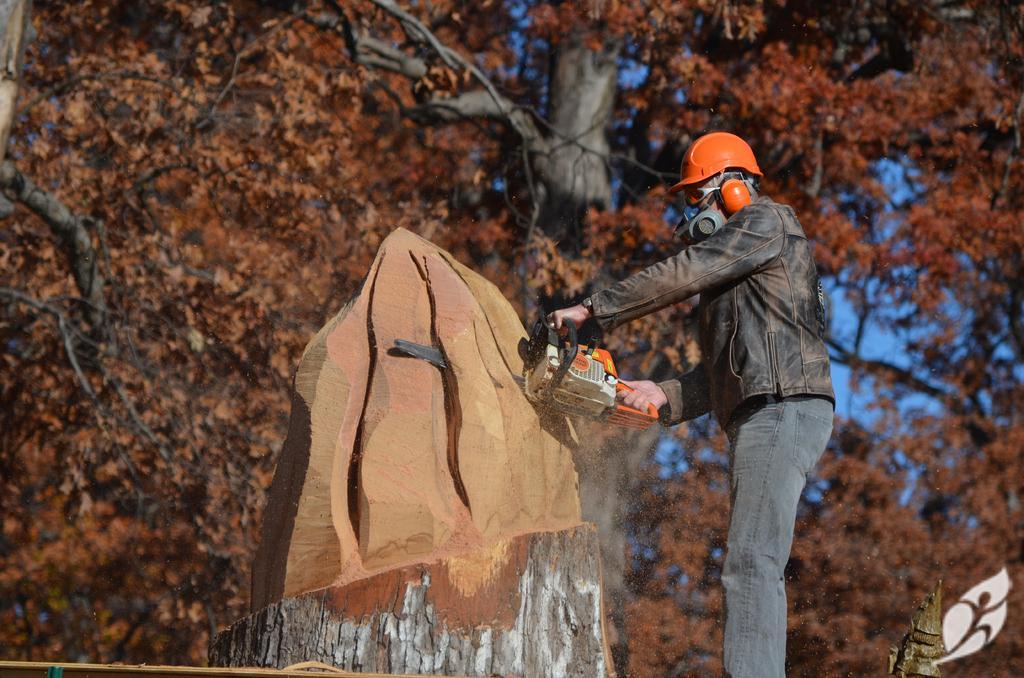In one or two sentences, can you explain what this image depicts? In this image I can see the person standing and holding some object. In the background I can see few trees and the sky is in blue color. In front I can see the trunk. 